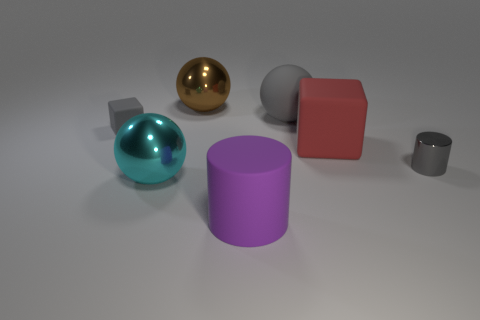Add 1 big metallic things. How many objects exist? 8 Subtract all cubes. How many objects are left? 5 Subtract all large green rubber blocks. Subtract all big metallic spheres. How many objects are left? 5 Add 2 large red rubber objects. How many large red rubber objects are left? 3 Add 5 small gray rubber objects. How many small gray rubber objects exist? 6 Subtract 0 purple balls. How many objects are left? 7 